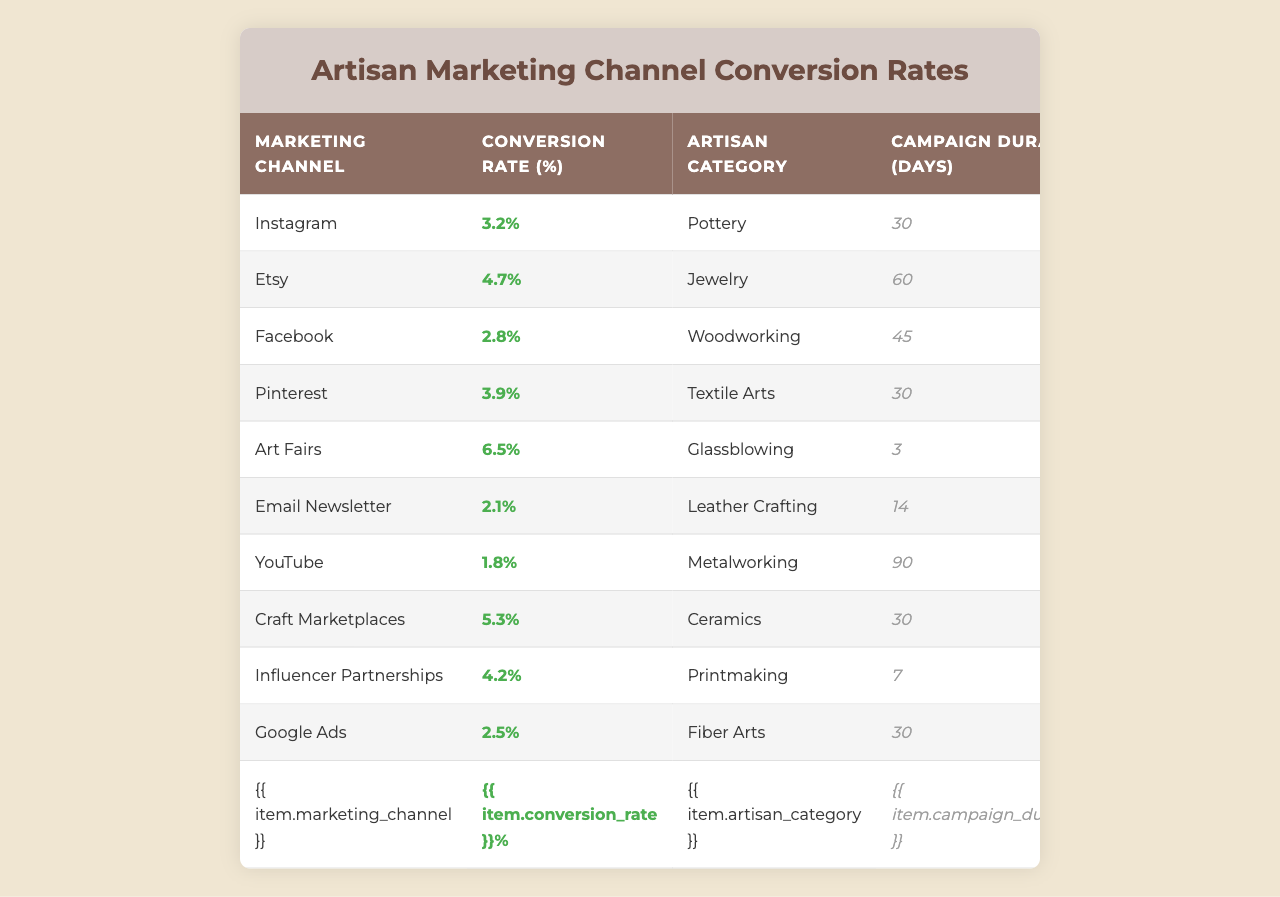What is the conversion rate for Instagram? The table shows the conversion rate for Instagram listed as 3.2%.
Answer: 3.2% Which marketing channel has the highest conversion rate? Scanning the table, Art Fairs have the highest conversion rate at 6.5%.
Answer: 6.5% What artisan category is associated with the lowest conversion rate? The lowest conversion rate of 1.8% is associated with Metalworking on YouTube.
Answer: Metalworking How long was the campaign duration for the Etsy marketing channel? The table indicates that the campaign duration for Etsy was 60 days.
Answer: 60 days Is the conversion rate for Craft Marketplaces higher than that for Email Newsletter? Craft Marketplaces have a conversion rate of 5.3% while Email Newsletter has 2.1%. Thus, it is true.
Answer: Yes What is the average conversion rate across all marketing channels listed? To find the average, add all conversion rates: (3.2 + 4.7 + 2.8 + 3.9 + 6.5 + 2.1 + 1.8 + 5.3 + 4.2 + 2.5) = 35.0, and divide by the number of channels (10), giving 3.5%.
Answer: 3.5% Comparing Facebook and Pinterest, which marketing channel has a better conversion rate? Facebook has a conversion rate of 2.8% and Pinterest has 3.9%; therefore, Pinterest is better.
Answer: Pinterest For how many days was the Art Fairs campaign conducted? The campaign duration for Art Fairs is stated as 3 days in the table.
Answer: 3 days Which artisan category had a campaign duration of 90 days? The table indicates that Metalworking had a campaign duration of 90 days.
Answer: Metalworking If we consider the conversion rates of the five channels: Instagram, Etsy, Craft Marketplaces, Facebook, and Email Newsletter, what is their collective conversion rate? Summing these specific channels gives 3.2 + 4.7 + 5.3 + 2.8 + 2.1 = 18.1%.
Answer: 18.1% Based on the data, can we say that Influencer Partnerships have a conversion rate lower than 5%? Influencer Partnerships have a conversion rate of 4.2%, which is indeed lower than 5%.
Answer: Yes 